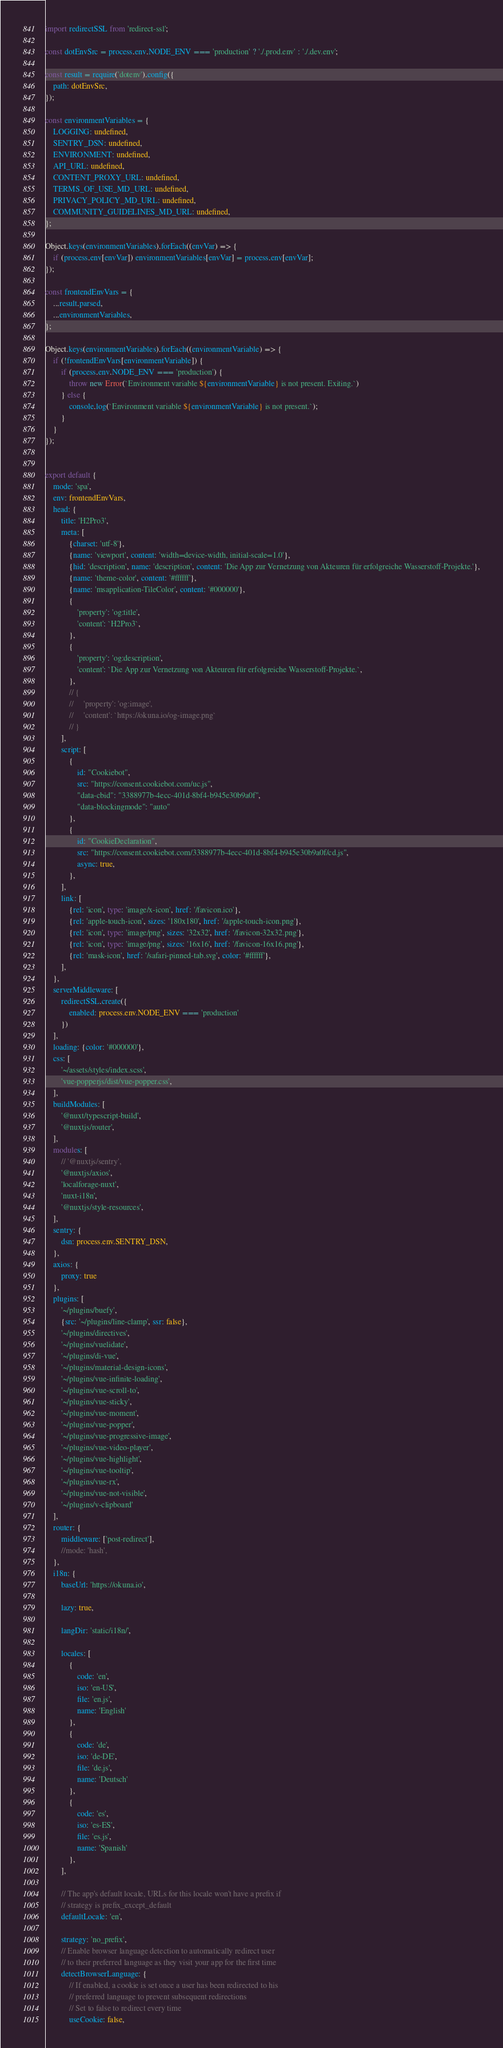<code> <loc_0><loc_0><loc_500><loc_500><_TypeScript_>import redirectSSL from 'redirect-ssl';

const dotEnvSrc = process.env.NODE_ENV === 'production' ? './.prod.env' : './.dev.env';

const result = require('dotenv').config({
    path: dotEnvSrc,
});

const environmentVariables = {
    LOGGING: undefined,
    SENTRY_DSN: undefined,
    ENVIRONMENT: undefined,
    API_URL: undefined,
    CONTENT_PROXY_URL: undefined,
    TERMS_OF_USE_MD_URL: undefined,
    PRIVACY_POLICY_MD_URL: undefined,
    COMMUNITY_GUIDELINES_MD_URL: undefined,
};

Object.keys(environmentVariables).forEach((envVar) => {
    if (process.env[envVar]) environmentVariables[envVar] = process.env[envVar];
});

const frontendEnvVars = {
    ...result.parsed,
    ...environmentVariables,
};

Object.keys(environmentVariables).forEach((environmentVariable) => {
    if (!frontendEnvVars[environmentVariable]) {
        if (process.env.NODE_ENV === 'production') {
            throw new Error(`Environment variable ${environmentVariable} is not present. Exiting.`)
        } else {
            console.log(`Environment variable ${environmentVariable} is not present.`);
        }
    }
});


export default {
    mode: 'spa',
    env: frontendEnvVars,
    head: {
        title: 'H2Pro3',
        meta: [
            {charset: 'utf-8'},
            {name: 'viewport', content: 'width=device-width, initial-scale=1.0'},
            {hid: 'description', name: 'description', content: 'Die App zur Vernetzung von Akteuren für erfolgreiche Wasserstoff-Projekte.'},
            {name: 'theme-color', content: '#ffffff'},
            {name: 'msapplication-TileColor', content: '#000000'},
            {
                'property': 'og:title',
                'content': `H2Pro3`,
            },
            {
                'property': 'og:description',
                'content': `Die App zur Vernetzung von Akteuren für erfolgreiche Wasserstoff-Projekte.`,
            },
            // {
            //     'property': 'og:image',
            //     'content': `https://okuna.io/og-image.png`
            // }
        ],
        script: [
            {
                id: "Cookiebot",
                src: "https://consent.cookiebot.com/uc.js",
                "data-cbid": "3388977b-4ecc-401d-8bf4-b945e30b9a0f",
                "data-blockingmode": "auto"
            },
            {
                id: "CookieDeclaration",
                src: "https://consent.cookiebot.com/3388977b-4ecc-401d-8bf4-b945e30b9a0f/cd.js",
                async: true,
            },
        ],
        link: [
            {rel: 'icon', type: 'image/x-icon', href: '/favicon.ico'},
            {rel: 'apple-touch-icon', sizes: '180x180', href: '/apple-touch-icon.png'},
            {rel: 'icon', type: 'image/png', sizes: '32x32', href: '/favicon-32x32.png'},
            {rel: 'icon', type: 'image/png', sizes: '16x16', href: '/favicon-16x16.png'},
            {rel: 'mask-icon', href: '/safari-pinned-tab.svg', color: '#ffffff'},
        ],
    },
    serverMiddleware: [
        redirectSSL.create({
            enabled: process.env.NODE_ENV === 'production'
        })
    ],
    loading: {color: '#000000'},
    css: [
        '~/assets/styles/index.scss',
        'vue-popperjs/dist/vue-popper.css',
    ],
    buildModules: [
        '@nuxt/typescript-build',
        '@nuxtjs/router',
    ],
    modules: [
        // '@nuxtjs/sentry',
        '@nuxtjs/axios',
        'localforage-nuxt',
        'nuxt-i18n',
        '@nuxtjs/style-resources',
    ],
    sentry: {
        dsn: process.env.SENTRY_DSN,
    },
    axios: {
        proxy: true
    },
    plugins: [
        '~/plugins/buefy',
        {src: '~/plugins/line-clamp', ssr: false},
        '~/plugins/directives',
        '~/plugins/vuelidate',
        '~/plugins/di-vue',
        '~/plugins/material-design-icons',
        '~/plugins/vue-infinite-loading',
        '~/plugins/vue-scroll-to',
        '~/plugins/vue-sticky',
        '~/plugins/vue-moment',
        '~/plugins/vue-popper',
        '~/plugins/vue-progressive-image',
        '~/plugins/vue-video-player',
        '~/plugins/vue-highlight',
        '~/plugins/vue-tooltip',
        '~/plugins/vue-rx',
        '~/plugins/vue-not-visible',
        '~/plugins/v-clipboard'
    ],
    router: {
        middleware: ['post-redirect'],
        //mode: 'hash',
    },
    i18n: {
        baseUrl: 'https://okuna.io',

        lazy: true,

        langDir: 'static/i18n/',

        locales: [
            {
                code: 'en',
                iso: 'en-US',
                file: 'en.js',
                name: 'English'
            },
            {
                code: 'de',
                iso: 'de-DE',
                file: 'de.js',
                name: 'Deutsch'
            },
            {
                code: 'es',
                iso: 'es-ES',
                file: 'es.js',
                name: 'Spanish'
            },
        ],

        // The app's default locale, URLs for this locale won't have a prefix if
        // strategy is prefix_except_default
        defaultLocale: 'en',

        strategy: 'no_prefix',
        // Enable browser language detection to automatically redirect user
        // to their preferred language as they visit your app for the first time
        detectBrowserLanguage: {
            // If enabled, a cookie is set once a user has been redirected to his
            // preferred language to prevent subsequent redirections
            // Set to false to redirect every time
            useCookie: false,</code> 